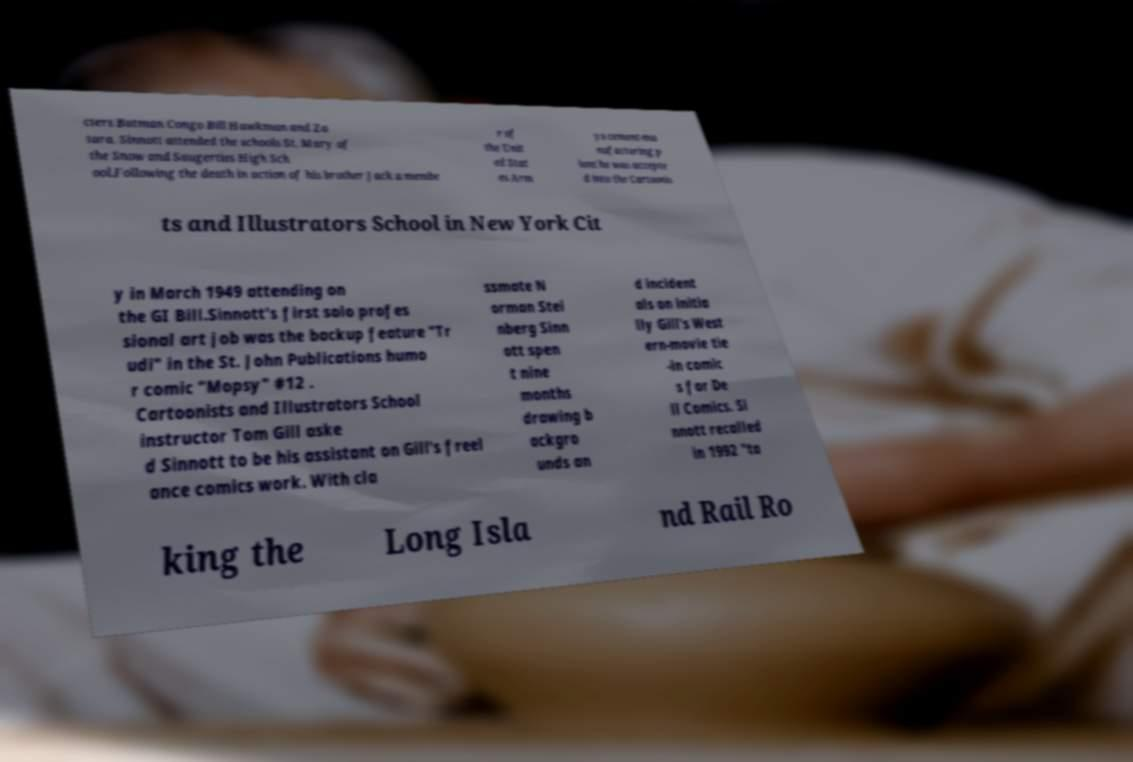Can you read and provide the text displayed in the image?This photo seems to have some interesting text. Can you extract and type it out for me? cters Batman Congo Bill Hawkman and Za tara. Sinnott attended the schools St. Mary of the Snow and Saugerties High Sch ool.Following the death in action of his brother Jack a membe r of the Unit ed Stat es Arm ys cement-ma nufacturing p lant he was accepte d into the Cartoonis ts and Illustrators School in New York Cit y in March 1949 attending on the GI Bill.Sinnott's first solo profes sional art job was the backup feature "Tr udi" in the St. John Publications humo r comic "Mopsy" #12 . Cartoonists and Illustrators School instructor Tom Gill aske d Sinnott to be his assistant on Gill's freel ance comics work. With cla ssmate N orman Stei nberg Sinn ott spen t nine months drawing b ackgro unds an d incident als on initia lly Gill's West ern-movie tie -in comic s for De ll Comics. Si nnott recalled in 1992 "ta king the Long Isla nd Rail Ro 